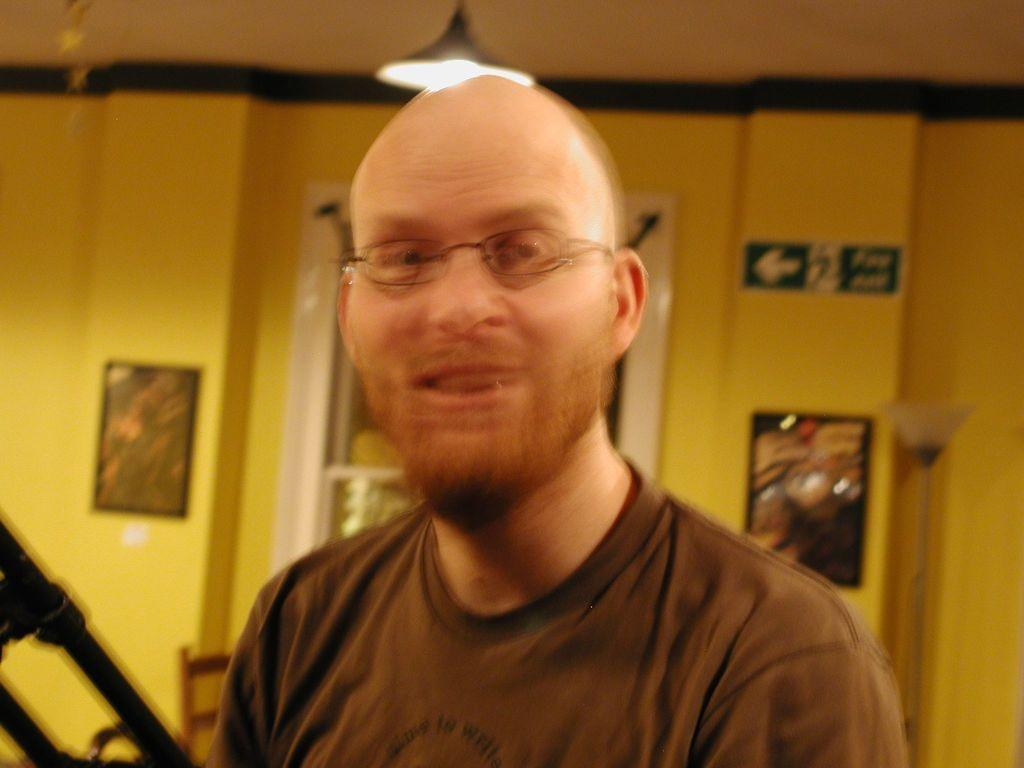Who is present in the image? There is a man in the image. What is the man wearing in the image? The man is wearing spectacles in the image. What can be seen on the wall in the background? There are photo frames on the wall in the background. What is the source of light in the image? There is a light on the top in the image. How many children are playing with the cloth in the image? There are no children or cloth present in the image. What type of thrill can be experienced by the man in the image? The image does not provide information about any thrilling experiences; it simply shows a man wearing spectacles. 